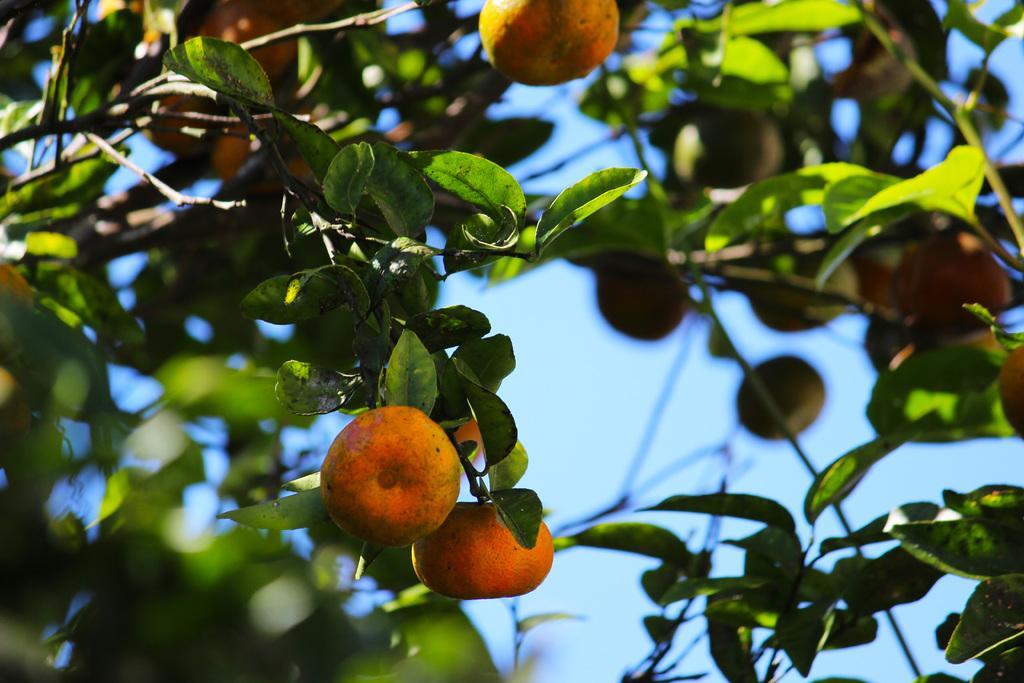Please provide a concise description of this image. In this picture we can see few fruits and trees. 